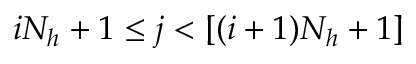<formula> <loc_0><loc_0><loc_500><loc_500>i N _ { h } + 1 \leq j < [ ( i + 1 ) N _ { h } + 1 ]</formula> 